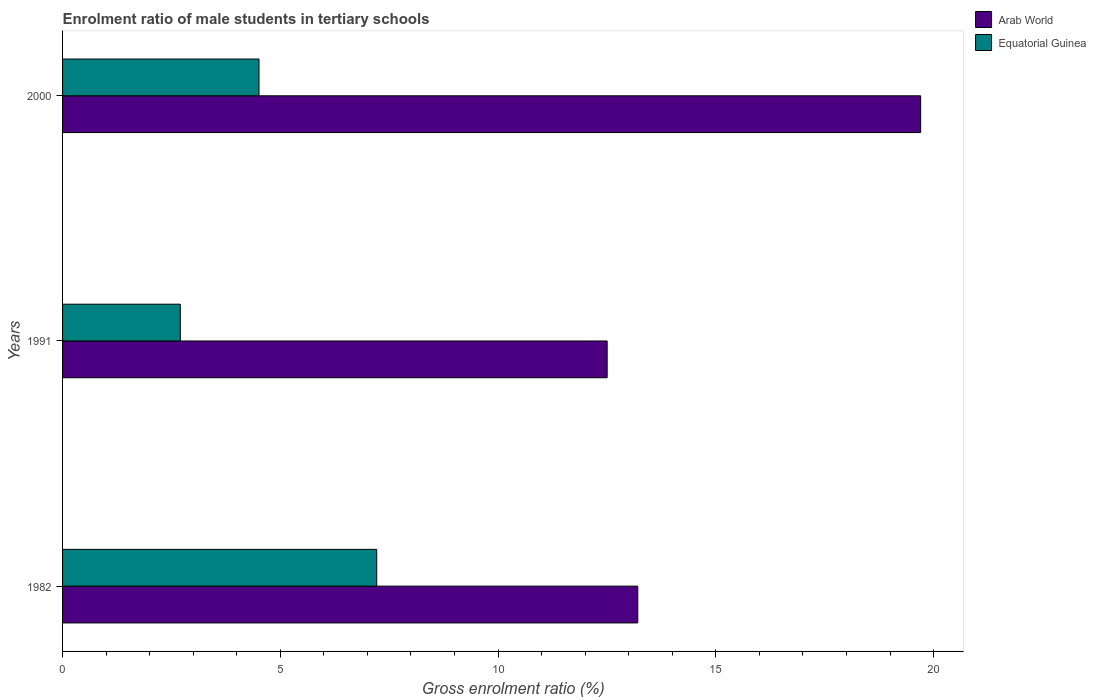Are the number of bars on each tick of the Y-axis equal?
Offer a terse response. Yes. How many bars are there on the 3rd tick from the top?
Your response must be concise. 2. How many bars are there on the 1st tick from the bottom?
Provide a short and direct response. 2. What is the enrolment ratio of male students in tertiary schools in Equatorial Guinea in 1991?
Give a very brief answer. 2.7. Across all years, what is the maximum enrolment ratio of male students in tertiary schools in Equatorial Guinea?
Give a very brief answer. 7.21. Across all years, what is the minimum enrolment ratio of male students in tertiary schools in Arab World?
Your answer should be compact. 12.5. What is the total enrolment ratio of male students in tertiary schools in Equatorial Guinea in the graph?
Your answer should be very brief. 14.43. What is the difference between the enrolment ratio of male students in tertiary schools in Arab World in 1991 and that in 2000?
Offer a terse response. -7.2. What is the difference between the enrolment ratio of male students in tertiary schools in Arab World in 2000 and the enrolment ratio of male students in tertiary schools in Equatorial Guinea in 1991?
Give a very brief answer. 17. What is the average enrolment ratio of male students in tertiary schools in Arab World per year?
Offer a very short reply. 15.14. In the year 1982, what is the difference between the enrolment ratio of male students in tertiary schools in Equatorial Guinea and enrolment ratio of male students in tertiary schools in Arab World?
Keep it short and to the point. -5.99. What is the ratio of the enrolment ratio of male students in tertiary schools in Arab World in 1982 to that in 1991?
Your response must be concise. 1.06. Is the difference between the enrolment ratio of male students in tertiary schools in Equatorial Guinea in 1982 and 1991 greater than the difference between the enrolment ratio of male students in tertiary schools in Arab World in 1982 and 1991?
Provide a succinct answer. Yes. What is the difference between the highest and the second highest enrolment ratio of male students in tertiary schools in Equatorial Guinea?
Offer a terse response. 2.7. What is the difference between the highest and the lowest enrolment ratio of male students in tertiary schools in Arab World?
Offer a very short reply. 7.2. In how many years, is the enrolment ratio of male students in tertiary schools in Equatorial Guinea greater than the average enrolment ratio of male students in tertiary schools in Equatorial Guinea taken over all years?
Ensure brevity in your answer.  1. Is the sum of the enrolment ratio of male students in tertiary schools in Arab World in 1982 and 1991 greater than the maximum enrolment ratio of male students in tertiary schools in Equatorial Guinea across all years?
Keep it short and to the point. Yes. What does the 2nd bar from the top in 1991 represents?
Give a very brief answer. Arab World. What does the 2nd bar from the bottom in 2000 represents?
Provide a short and direct response. Equatorial Guinea. Are all the bars in the graph horizontal?
Offer a terse response. Yes. Are the values on the major ticks of X-axis written in scientific E-notation?
Your response must be concise. No. How many legend labels are there?
Make the answer very short. 2. What is the title of the graph?
Your answer should be very brief. Enrolment ratio of male students in tertiary schools. Does "Bermuda" appear as one of the legend labels in the graph?
Give a very brief answer. No. What is the label or title of the X-axis?
Offer a terse response. Gross enrolment ratio (%). What is the label or title of the Y-axis?
Ensure brevity in your answer.  Years. What is the Gross enrolment ratio (%) of Arab World in 1982?
Provide a short and direct response. 13.21. What is the Gross enrolment ratio (%) of Equatorial Guinea in 1982?
Provide a short and direct response. 7.21. What is the Gross enrolment ratio (%) in Arab World in 1991?
Provide a short and direct response. 12.5. What is the Gross enrolment ratio (%) of Equatorial Guinea in 1991?
Offer a very short reply. 2.7. What is the Gross enrolment ratio (%) in Arab World in 2000?
Keep it short and to the point. 19.7. What is the Gross enrolment ratio (%) of Equatorial Guinea in 2000?
Keep it short and to the point. 4.51. Across all years, what is the maximum Gross enrolment ratio (%) in Arab World?
Keep it short and to the point. 19.7. Across all years, what is the maximum Gross enrolment ratio (%) of Equatorial Guinea?
Ensure brevity in your answer.  7.21. Across all years, what is the minimum Gross enrolment ratio (%) of Arab World?
Your answer should be compact. 12.5. Across all years, what is the minimum Gross enrolment ratio (%) in Equatorial Guinea?
Ensure brevity in your answer.  2.7. What is the total Gross enrolment ratio (%) of Arab World in the graph?
Provide a succinct answer. 45.42. What is the total Gross enrolment ratio (%) in Equatorial Guinea in the graph?
Your answer should be compact. 14.43. What is the difference between the Gross enrolment ratio (%) of Arab World in 1982 and that in 1991?
Offer a very short reply. 0.7. What is the difference between the Gross enrolment ratio (%) in Equatorial Guinea in 1982 and that in 1991?
Provide a succinct answer. 4.51. What is the difference between the Gross enrolment ratio (%) in Arab World in 1982 and that in 2000?
Provide a succinct answer. -6.5. What is the difference between the Gross enrolment ratio (%) of Equatorial Guinea in 1982 and that in 2000?
Ensure brevity in your answer.  2.7. What is the difference between the Gross enrolment ratio (%) of Arab World in 1991 and that in 2000?
Offer a terse response. -7.2. What is the difference between the Gross enrolment ratio (%) in Equatorial Guinea in 1991 and that in 2000?
Keep it short and to the point. -1.81. What is the difference between the Gross enrolment ratio (%) of Arab World in 1982 and the Gross enrolment ratio (%) of Equatorial Guinea in 1991?
Make the answer very short. 10.5. What is the difference between the Gross enrolment ratio (%) of Arab World in 1982 and the Gross enrolment ratio (%) of Equatorial Guinea in 2000?
Ensure brevity in your answer.  8.7. What is the difference between the Gross enrolment ratio (%) of Arab World in 1991 and the Gross enrolment ratio (%) of Equatorial Guinea in 2000?
Make the answer very short. 7.99. What is the average Gross enrolment ratio (%) in Arab World per year?
Provide a short and direct response. 15.14. What is the average Gross enrolment ratio (%) in Equatorial Guinea per year?
Ensure brevity in your answer.  4.81. In the year 1982, what is the difference between the Gross enrolment ratio (%) of Arab World and Gross enrolment ratio (%) of Equatorial Guinea?
Your answer should be compact. 5.99. In the year 1991, what is the difference between the Gross enrolment ratio (%) of Arab World and Gross enrolment ratio (%) of Equatorial Guinea?
Your answer should be very brief. 9.8. In the year 2000, what is the difference between the Gross enrolment ratio (%) of Arab World and Gross enrolment ratio (%) of Equatorial Guinea?
Ensure brevity in your answer.  15.19. What is the ratio of the Gross enrolment ratio (%) of Arab World in 1982 to that in 1991?
Make the answer very short. 1.06. What is the ratio of the Gross enrolment ratio (%) of Equatorial Guinea in 1982 to that in 1991?
Offer a very short reply. 2.67. What is the ratio of the Gross enrolment ratio (%) in Arab World in 1982 to that in 2000?
Your answer should be compact. 0.67. What is the ratio of the Gross enrolment ratio (%) of Equatorial Guinea in 1982 to that in 2000?
Provide a short and direct response. 1.6. What is the ratio of the Gross enrolment ratio (%) in Arab World in 1991 to that in 2000?
Make the answer very short. 0.63. What is the ratio of the Gross enrolment ratio (%) in Equatorial Guinea in 1991 to that in 2000?
Your response must be concise. 0.6. What is the difference between the highest and the second highest Gross enrolment ratio (%) in Arab World?
Your response must be concise. 6.5. What is the difference between the highest and the second highest Gross enrolment ratio (%) of Equatorial Guinea?
Ensure brevity in your answer.  2.7. What is the difference between the highest and the lowest Gross enrolment ratio (%) in Arab World?
Make the answer very short. 7.2. What is the difference between the highest and the lowest Gross enrolment ratio (%) of Equatorial Guinea?
Provide a short and direct response. 4.51. 